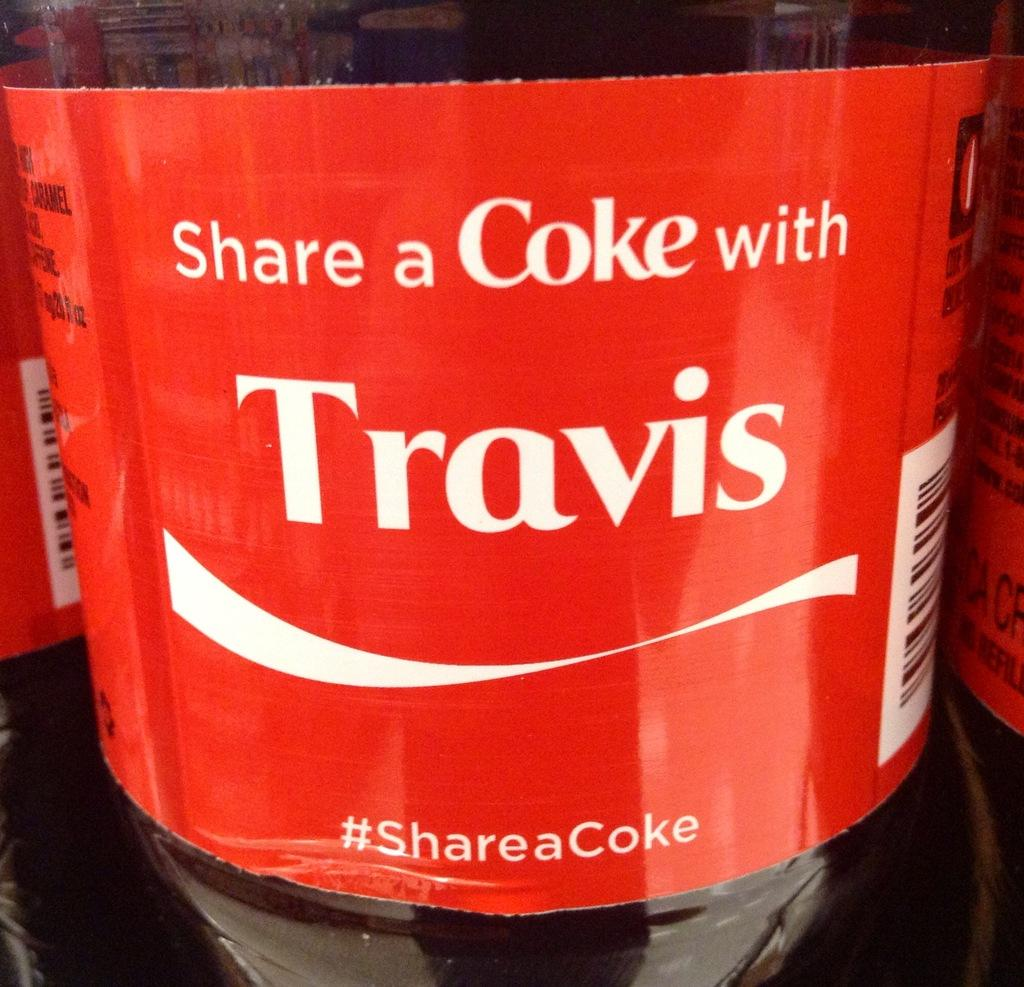<image>
Provide a brief description of the given image. The label on a Coke bottle with a slogan that reads Share a Coke with Travis. 